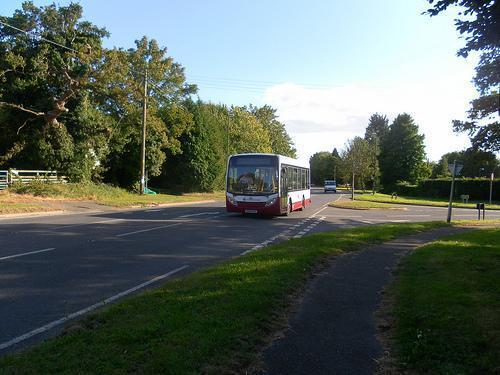How many buses on the road?
Give a very brief answer. 1. 